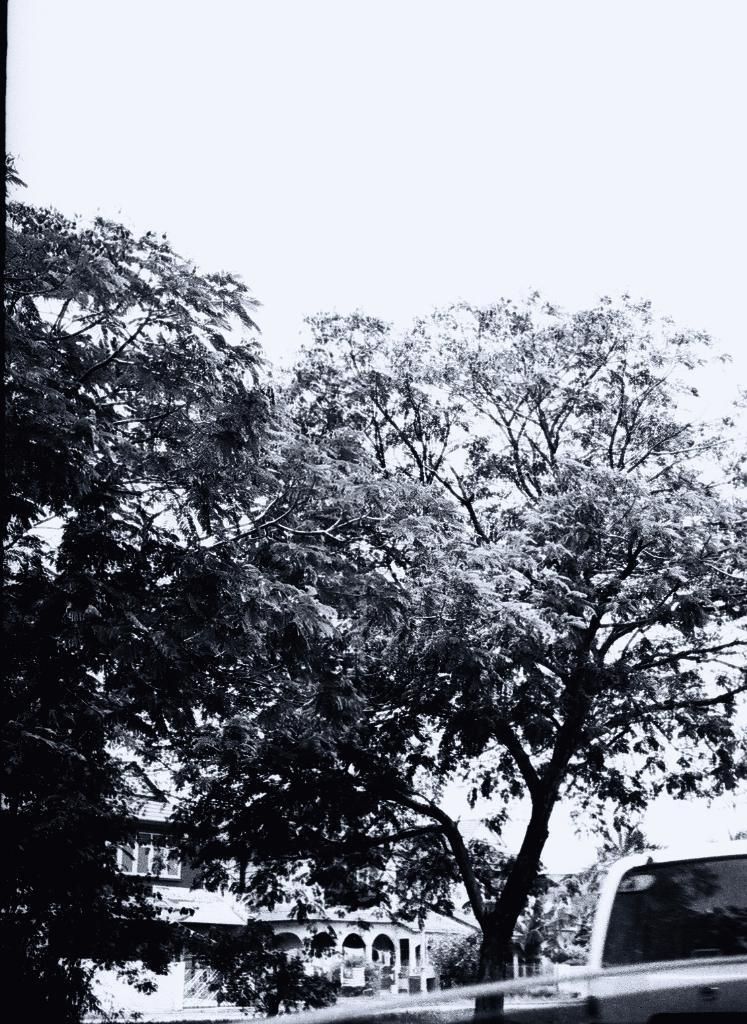What is the color scheme of the image? The image is black and white. What type of structure can be seen in the image? There is a building in the image. What architectural feature is present in the building? There are windows in the image. What type of natural elements are present in the image? There are trees in the image. What objects can be seen at the bottom portion of the image? There are objects at the bottom portion of the image. What is the position of the airplane in the image? There is no airplane present in the image. What does the mouth of the building look like in the image? Buildings do not have mouths, as they are inanimate structures. 